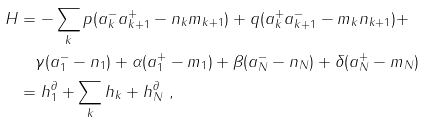Convert formula to latex. <formula><loc_0><loc_0><loc_500><loc_500>H & = - \sum _ { k } p ( a _ { k } ^ { - } a _ { k + 1 } ^ { + } - n _ { k } m _ { k + 1 } ) + q ( a _ { k } ^ { + } a _ { k + 1 } ^ { - } - m _ { k } n _ { k + 1 } ) + \\ & \quad \gamma ( a ^ { - } _ { 1 } - n _ { 1 } ) + \alpha ( a ^ { + } _ { 1 } - m _ { 1 } ) + \beta ( a ^ { - } _ { N } - n _ { N } ) + \delta ( a ^ { + } _ { N } - m _ { N } ) \\ & = h _ { 1 } ^ { \partial } + \sum _ { k } h _ { k } + h _ { N } ^ { \partial } \ ,</formula> 